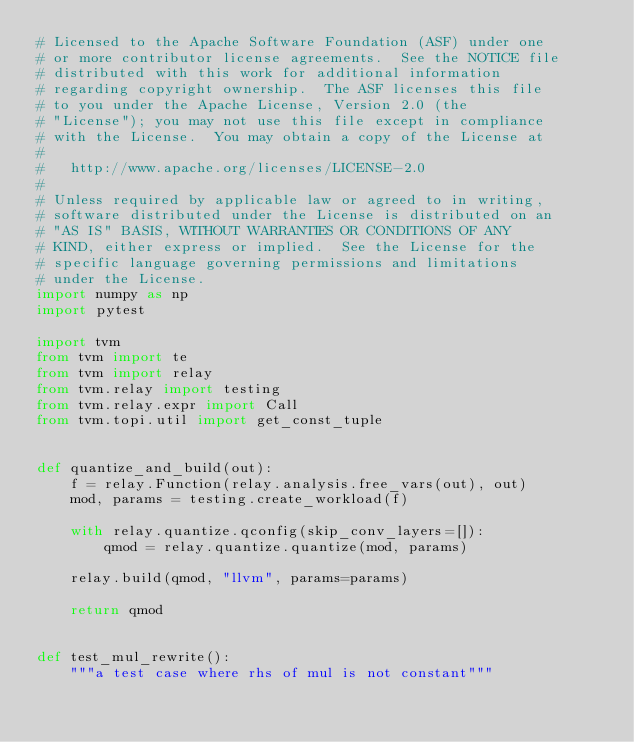Convert code to text. <code><loc_0><loc_0><loc_500><loc_500><_Python_># Licensed to the Apache Software Foundation (ASF) under one
# or more contributor license agreements.  See the NOTICE file
# distributed with this work for additional information
# regarding copyright ownership.  The ASF licenses this file
# to you under the Apache License, Version 2.0 (the
# "License"); you may not use this file except in compliance
# with the License.  You may obtain a copy of the License at
#
#   http://www.apache.org/licenses/LICENSE-2.0
#
# Unless required by applicable law or agreed to in writing,
# software distributed under the License is distributed on an
# "AS IS" BASIS, WITHOUT WARRANTIES OR CONDITIONS OF ANY
# KIND, either express or implied.  See the License for the
# specific language governing permissions and limitations
# under the License.
import numpy as np
import pytest

import tvm
from tvm import te
from tvm import relay
from tvm.relay import testing
from tvm.relay.expr import Call
from tvm.topi.util import get_const_tuple


def quantize_and_build(out):
    f = relay.Function(relay.analysis.free_vars(out), out)
    mod, params = testing.create_workload(f)

    with relay.quantize.qconfig(skip_conv_layers=[]):
        qmod = relay.quantize.quantize(mod, params)

    relay.build(qmod, "llvm", params=params)

    return qmod


def test_mul_rewrite():
    """a test case where rhs of mul is not constant"""</code> 